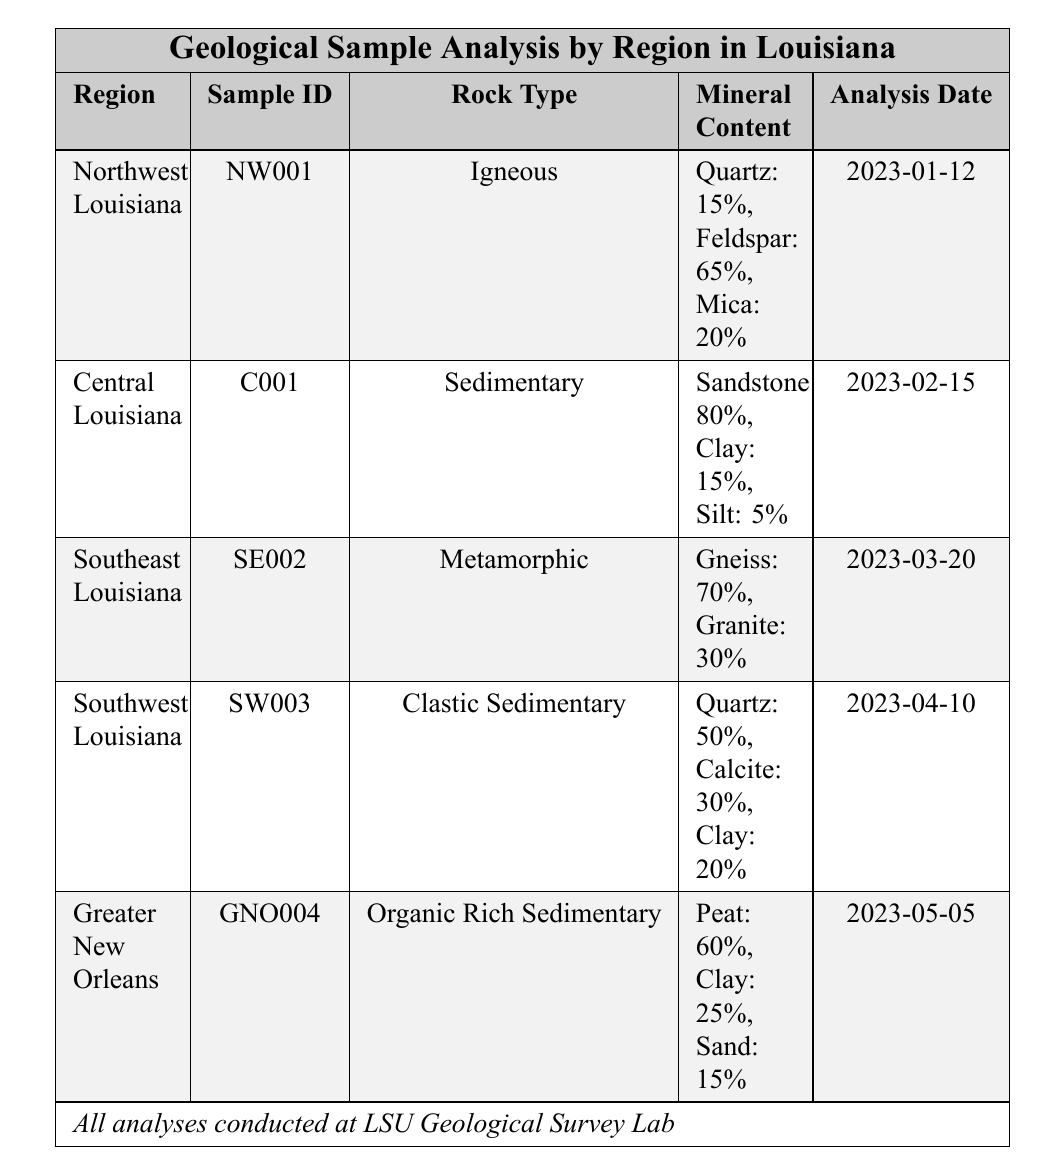What is the rock type of the sample collected from Central Louisiana? The table states that the sample from Central Louisiana has the Sample ID C001 and lists the Rock Type as Sedimentary.
Answer: Sedimentary How many different types of minerals are present in the sample from Northwest Louisiana? The sample from Northwest Louisiana (Sample ID NW001) contains three minerals: Quartz, Feldspar, and Mica, which can be counted directly from the mineral content column.
Answer: Three What percentage of the mineral content in the Southeast Louisiana sample is Gneiss? The table shows that in the Southeast Louisiana sample (Sample ID SE002), Gneiss makes up 70% of the mineral content as stated directly in the mineral content column.
Answer: 70% Is there any igneous rock type sample analyzed in Southwest Louisiana? The sample from Southwest Louisiana (Sample ID SW003) is categorized as clastic sedimentary rock, therefore it is not igneous. The fact can be determined by checking the Rock Type column.
Answer: No What is the total percentage of clay present in the samples from Southwest Louisiana and Greater New Orleans? In Southwest Louisiana, the clay content is 20%, and in Greater New Orleans, it is 25%. Combining these percentages (20% + 25%) yields a total of 45%.
Answer: 45% Which region has the highest mineral content of a single type and what is that mineral? In the sample from Central Louisiana (Sample ID C001), Sandstone constitutes 80% of the mineral content, which is the highest percentage compared to any other sample in the table.
Answer: Central Louisiana, Sandstone What rock type has the least mineral diversity based on the samples collected? The sample from Southeast Louisiana (Sample ID SE002) has the least mineral diversity, containing only two types: Gneiss and Granite. All other samples have three or more types.
Answer: Metamorphic Was the sample with the highest mineral content analyzed the earliest or latest? The sample from Central Louisiana (Sample ID C001), with the highest mineral content of Sandstone (80%), was analyzed on February 15, 2023, which is earlier than the sample from Greater New Orleans (GNO004) analyzed on May 5, 2023.
Answer: Earliest 